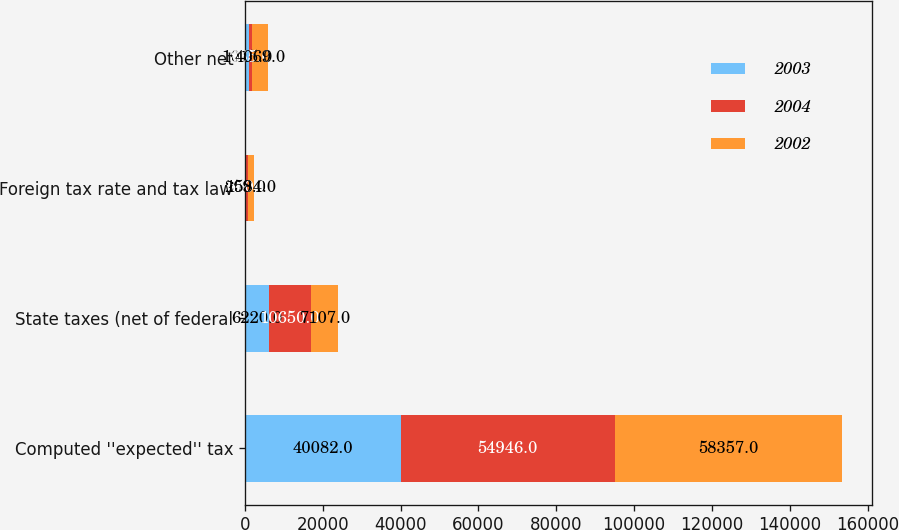Convert chart. <chart><loc_0><loc_0><loc_500><loc_500><stacked_bar_chart><ecel><fcel>Computed ''expected'' tax<fcel>State taxes (net of federal<fcel>Foreign tax rate and tax law<fcel>Other net<nl><fcel>2003<fcel>40082<fcel>6220<fcel>209<fcel>1015<nl><fcel>2004<fcel>54946<fcel>10650<fcel>540<fcel>865<nl><fcel>2002<fcel>58357<fcel>7107<fcel>1584<fcel>4069<nl></chart> 